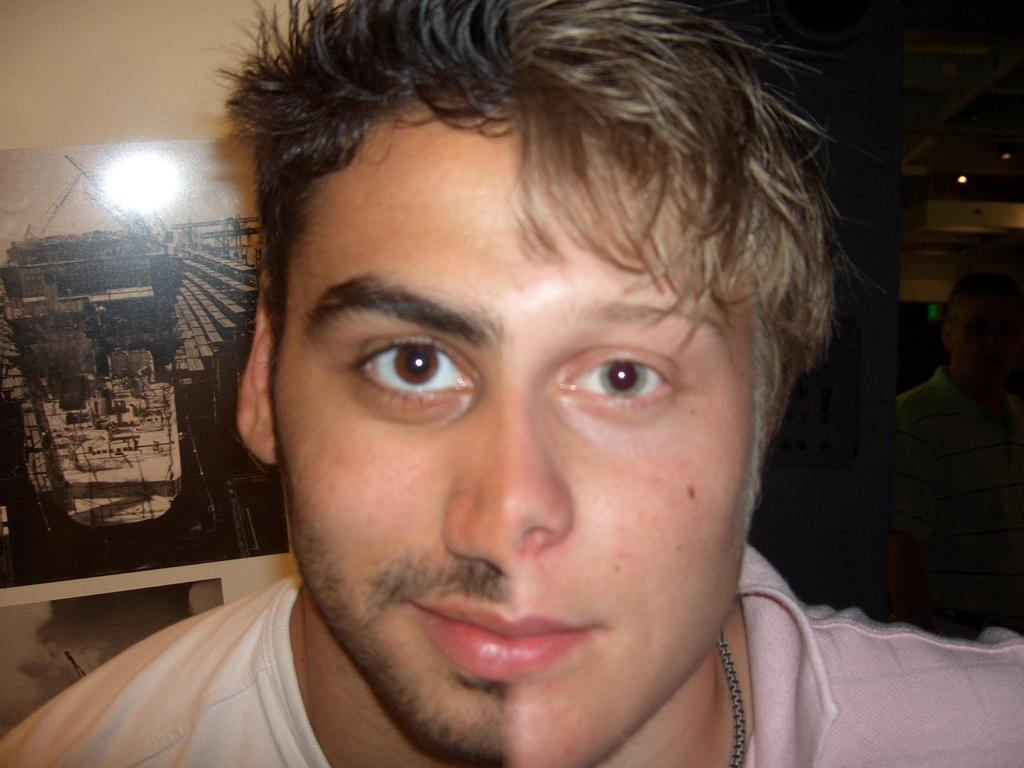What is unique about the image in terms of the faces? There are two persons' faces combined into one in the image. What can be seen on the right side of the image? There is a dark area on the right side of the image. What is attached to the wall on the left side of the image? There is a photo frame attached to the wall on the left side of the image. What type of snail can be seen crawling on the photo frame in the image? There is no snail present in the image; it only features a combined face and a photo frame on the wall. 